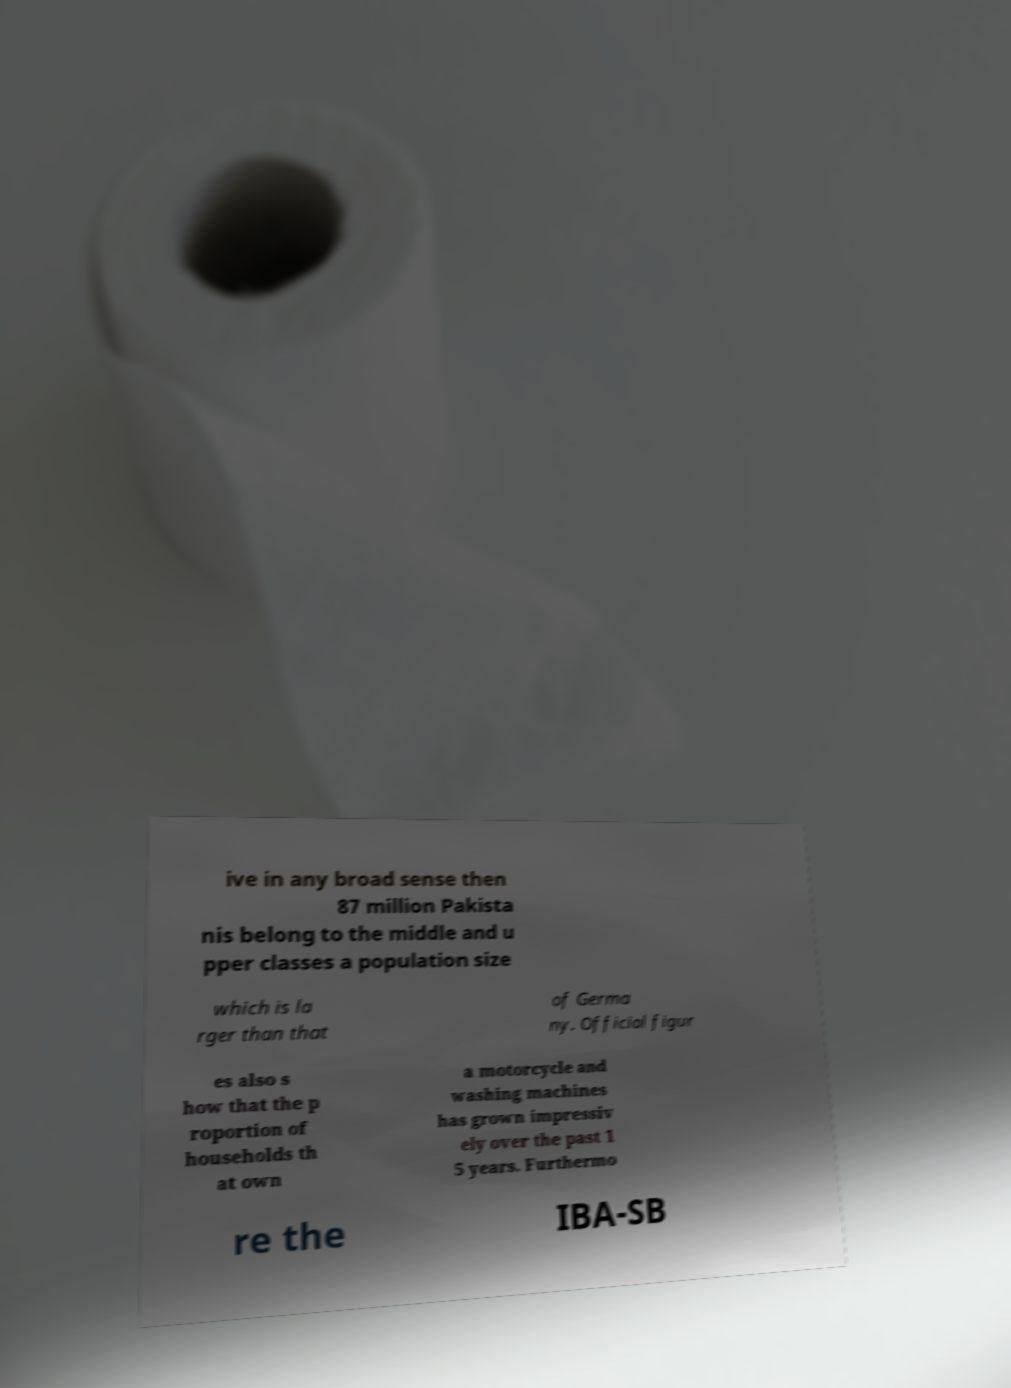Could you assist in decoding the text presented in this image and type it out clearly? ive in any broad sense then 87 million Pakista nis belong to the middle and u pper classes a population size which is la rger than that of Germa ny. Official figur es also s how that the p roportion of households th at own a motorcycle and washing machines has grown impressiv ely over the past 1 5 years. Furthermo re the IBA-SB 